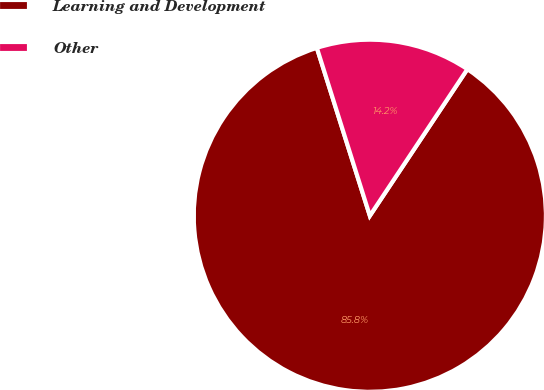Convert chart. <chart><loc_0><loc_0><loc_500><loc_500><pie_chart><fcel>Learning and Development<fcel>Other<nl><fcel>85.79%<fcel>14.21%<nl></chart> 